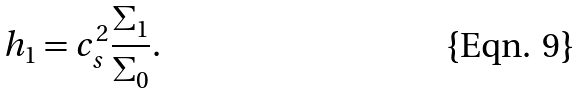Convert formula to latex. <formula><loc_0><loc_0><loc_500><loc_500>h _ { 1 } = c _ { s } ^ { 2 } \frac { \Sigma _ { 1 } } { \Sigma _ { 0 } } .</formula> 